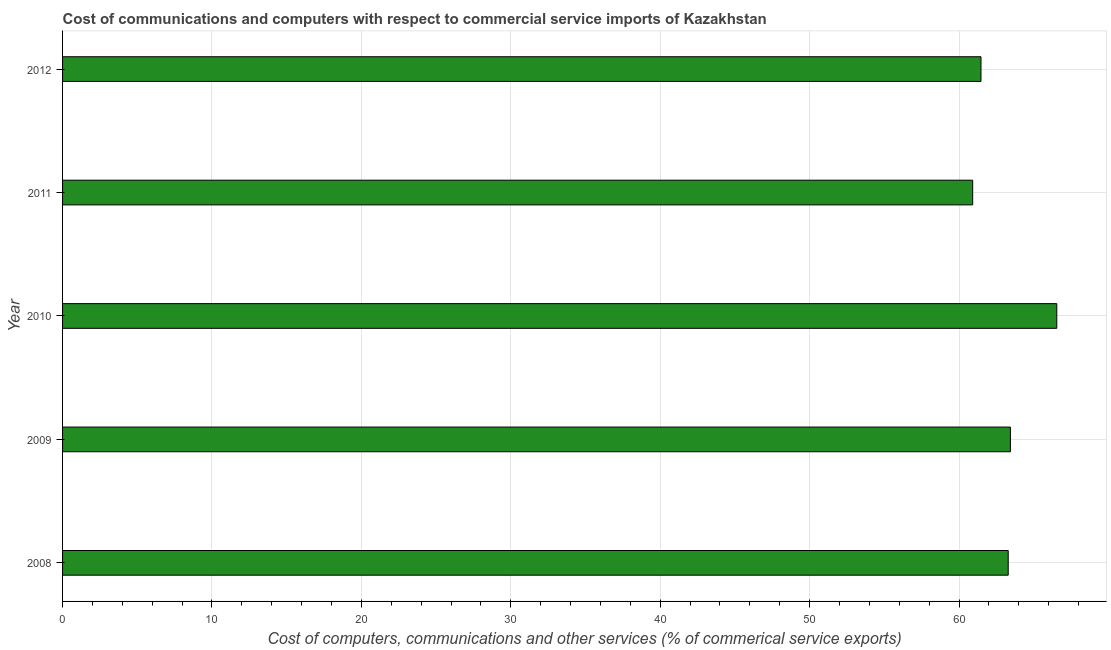Does the graph contain any zero values?
Your answer should be very brief. No. Does the graph contain grids?
Make the answer very short. Yes. What is the title of the graph?
Provide a short and direct response. Cost of communications and computers with respect to commercial service imports of Kazakhstan. What is the label or title of the X-axis?
Your answer should be very brief. Cost of computers, communications and other services (% of commerical service exports). What is the label or title of the Y-axis?
Provide a short and direct response. Year. What is the  computer and other services in 2012?
Your response must be concise. 61.47. Across all years, what is the maximum cost of communications?
Provide a succinct answer. 66.54. Across all years, what is the minimum cost of communications?
Your answer should be very brief. 60.91. In which year was the  computer and other services maximum?
Offer a very short reply. 2010. In which year was the  computer and other services minimum?
Keep it short and to the point. 2011. What is the sum of the cost of communications?
Keep it short and to the point. 315.65. What is the difference between the cost of communications in 2008 and 2009?
Ensure brevity in your answer.  -0.15. What is the average cost of communications per year?
Give a very brief answer. 63.13. What is the median cost of communications?
Keep it short and to the point. 63.29. What is the ratio of the cost of communications in 2010 to that in 2012?
Ensure brevity in your answer.  1.08. What is the difference between the highest and the second highest cost of communications?
Offer a terse response. 3.1. What is the difference between the highest and the lowest cost of communications?
Provide a short and direct response. 5.63. In how many years, is the cost of communications greater than the average cost of communications taken over all years?
Keep it short and to the point. 3. How many years are there in the graph?
Ensure brevity in your answer.  5. Are the values on the major ticks of X-axis written in scientific E-notation?
Keep it short and to the point. No. What is the Cost of computers, communications and other services (% of commerical service exports) in 2008?
Offer a terse response. 63.29. What is the Cost of computers, communications and other services (% of commerical service exports) in 2009?
Keep it short and to the point. 63.44. What is the Cost of computers, communications and other services (% of commerical service exports) of 2010?
Offer a very short reply. 66.54. What is the Cost of computers, communications and other services (% of commerical service exports) in 2011?
Give a very brief answer. 60.91. What is the Cost of computers, communications and other services (% of commerical service exports) in 2012?
Make the answer very short. 61.47. What is the difference between the Cost of computers, communications and other services (% of commerical service exports) in 2008 and 2009?
Offer a terse response. -0.15. What is the difference between the Cost of computers, communications and other services (% of commerical service exports) in 2008 and 2010?
Offer a very short reply. -3.25. What is the difference between the Cost of computers, communications and other services (% of commerical service exports) in 2008 and 2011?
Provide a short and direct response. 2.38. What is the difference between the Cost of computers, communications and other services (% of commerical service exports) in 2008 and 2012?
Give a very brief answer. 1.82. What is the difference between the Cost of computers, communications and other services (% of commerical service exports) in 2009 and 2010?
Offer a very short reply. -3.1. What is the difference between the Cost of computers, communications and other services (% of commerical service exports) in 2009 and 2011?
Offer a terse response. 2.52. What is the difference between the Cost of computers, communications and other services (% of commerical service exports) in 2009 and 2012?
Your answer should be very brief. 1.97. What is the difference between the Cost of computers, communications and other services (% of commerical service exports) in 2010 and 2011?
Offer a terse response. 5.63. What is the difference between the Cost of computers, communications and other services (% of commerical service exports) in 2010 and 2012?
Keep it short and to the point. 5.07. What is the difference between the Cost of computers, communications and other services (% of commerical service exports) in 2011 and 2012?
Your response must be concise. -0.56. What is the ratio of the Cost of computers, communications and other services (% of commerical service exports) in 2008 to that in 2010?
Keep it short and to the point. 0.95. What is the ratio of the Cost of computers, communications and other services (% of commerical service exports) in 2008 to that in 2011?
Give a very brief answer. 1.04. What is the ratio of the Cost of computers, communications and other services (% of commerical service exports) in 2008 to that in 2012?
Offer a terse response. 1.03. What is the ratio of the Cost of computers, communications and other services (% of commerical service exports) in 2009 to that in 2010?
Your answer should be compact. 0.95. What is the ratio of the Cost of computers, communications and other services (% of commerical service exports) in 2009 to that in 2011?
Provide a short and direct response. 1.04. What is the ratio of the Cost of computers, communications and other services (% of commerical service exports) in 2009 to that in 2012?
Your answer should be very brief. 1.03. What is the ratio of the Cost of computers, communications and other services (% of commerical service exports) in 2010 to that in 2011?
Offer a terse response. 1.09. What is the ratio of the Cost of computers, communications and other services (% of commerical service exports) in 2010 to that in 2012?
Your response must be concise. 1.08. What is the ratio of the Cost of computers, communications and other services (% of commerical service exports) in 2011 to that in 2012?
Your response must be concise. 0.99. 